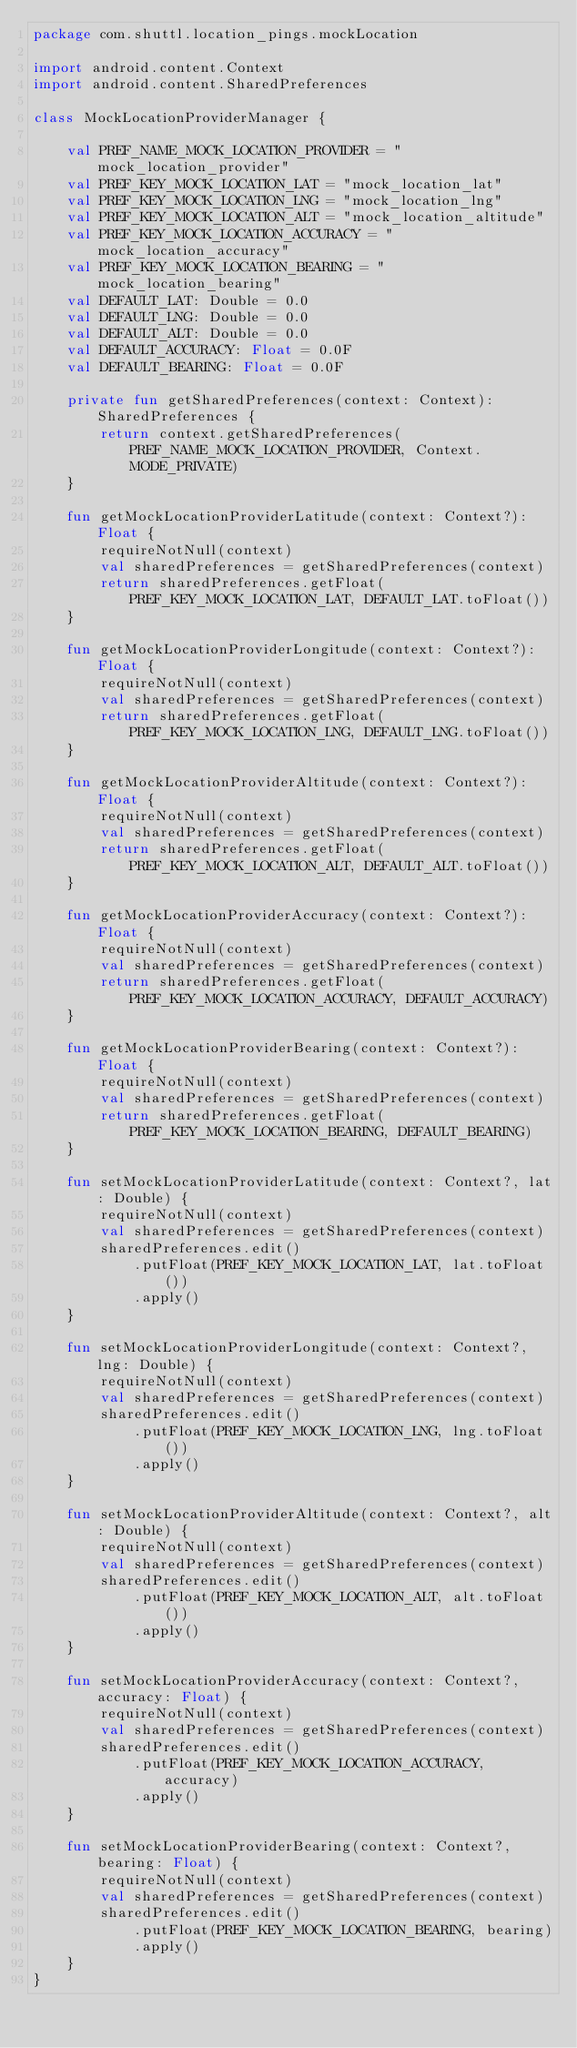Convert code to text. <code><loc_0><loc_0><loc_500><loc_500><_Kotlin_>package com.shuttl.location_pings.mockLocation

import android.content.Context
import android.content.SharedPreferences

class MockLocationProviderManager {

    val PREF_NAME_MOCK_LOCATION_PROVIDER = "mock_location_provider"
    val PREF_KEY_MOCK_LOCATION_LAT = "mock_location_lat"
    val PREF_KEY_MOCK_LOCATION_LNG = "mock_location_lng"
    val PREF_KEY_MOCK_LOCATION_ALT = "mock_location_altitude"
    val PREF_KEY_MOCK_LOCATION_ACCURACY = "mock_location_accuracy"
    val PREF_KEY_MOCK_LOCATION_BEARING = "mock_location_bearing"
    val DEFAULT_LAT: Double = 0.0
    val DEFAULT_LNG: Double = 0.0
    val DEFAULT_ALT: Double = 0.0
    val DEFAULT_ACCURACY: Float = 0.0F
    val DEFAULT_BEARING: Float = 0.0F

    private fun getSharedPreferences(context: Context): SharedPreferences {
        return context.getSharedPreferences(PREF_NAME_MOCK_LOCATION_PROVIDER, Context.MODE_PRIVATE)
    }

    fun getMockLocationProviderLatitude(context: Context?): Float {
        requireNotNull(context)
        val sharedPreferences = getSharedPreferences(context)
        return sharedPreferences.getFloat(PREF_KEY_MOCK_LOCATION_LAT, DEFAULT_LAT.toFloat())
    }

    fun getMockLocationProviderLongitude(context: Context?): Float {
        requireNotNull(context)
        val sharedPreferences = getSharedPreferences(context)
        return sharedPreferences.getFloat(PREF_KEY_MOCK_LOCATION_LNG, DEFAULT_LNG.toFloat())
    }

    fun getMockLocationProviderAltitude(context: Context?): Float {
        requireNotNull(context)
        val sharedPreferences = getSharedPreferences(context)
        return sharedPreferences.getFloat(PREF_KEY_MOCK_LOCATION_ALT, DEFAULT_ALT.toFloat())
    }

    fun getMockLocationProviderAccuracy(context: Context?): Float {
        requireNotNull(context)
        val sharedPreferences = getSharedPreferences(context)
        return sharedPreferences.getFloat(PREF_KEY_MOCK_LOCATION_ACCURACY, DEFAULT_ACCURACY)
    }

    fun getMockLocationProviderBearing(context: Context?): Float {
        requireNotNull(context)
        val sharedPreferences = getSharedPreferences(context)
        return sharedPreferences.getFloat(PREF_KEY_MOCK_LOCATION_BEARING, DEFAULT_BEARING)
    }

    fun setMockLocationProviderLatitude(context: Context?, lat: Double) {
        requireNotNull(context)
        val sharedPreferences = getSharedPreferences(context)
        sharedPreferences.edit()
            .putFloat(PREF_KEY_MOCK_LOCATION_LAT, lat.toFloat())
            .apply()
    }

    fun setMockLocationProviderLongitude(context: Context?, lng: Double) {
        requireNotNull(context)
        val sharedPreferences = getSharedPreferences(context)
        sharedPreferences.edit()
            .putFloat(PREF_KEY_MOCK_LOCATION_LNG, lng.toFloat())
            .apply()
    }

    fun setMockLocationProviderAltitude(context: Context?, alt: Double) {
        requireNotNull(context)
        val sharedPreferences = getSharedPreferences(context)
        sharedPreferences.edit()
            .putFloat(PREF_KEY_MOCK_LOCATION_ALT, alt.toFloat())
            .apply()
    }

    fun setMockLocationProviderAccuracy(context: Context?, accuracy: Float) {
        requireNotNull(context)
        val sharedPreferences = getSharedPreferences(context)
        sharedPreferences.edit()
            .putFloat(PREF_KEY_MOCK_LOCATION_ACCURACY, accuracy)
            .apply()
    }

    fun setMockLocationProviderBearing(context: Context?, bearing: Float) {
        requireNotNull(context)
        val sharedPreferences = getSharedPreferences(context)
        sharedPreferences.edit()
            .putFloat(PREF_KEY_MOCK_LOCATION_BEARING, bearing)
            .apply()
    }
}</code> 